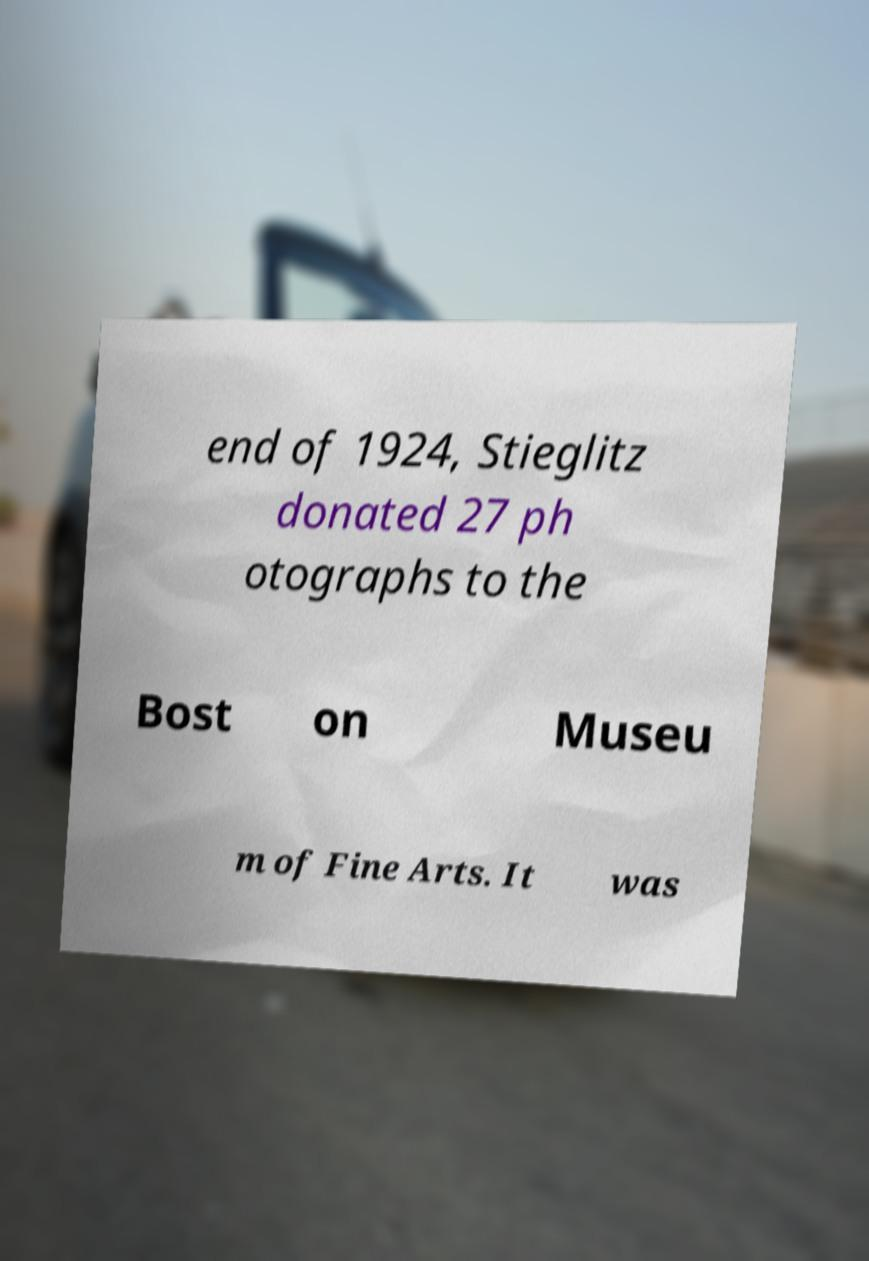Can you read and provide the text displayed in the image?This photo seems to have some interesting text. Can you extract and type it out for me? end of 1924, Stieglitz donated 27 ph otographs to the Bost on Museu m of Fine Arts. It was 